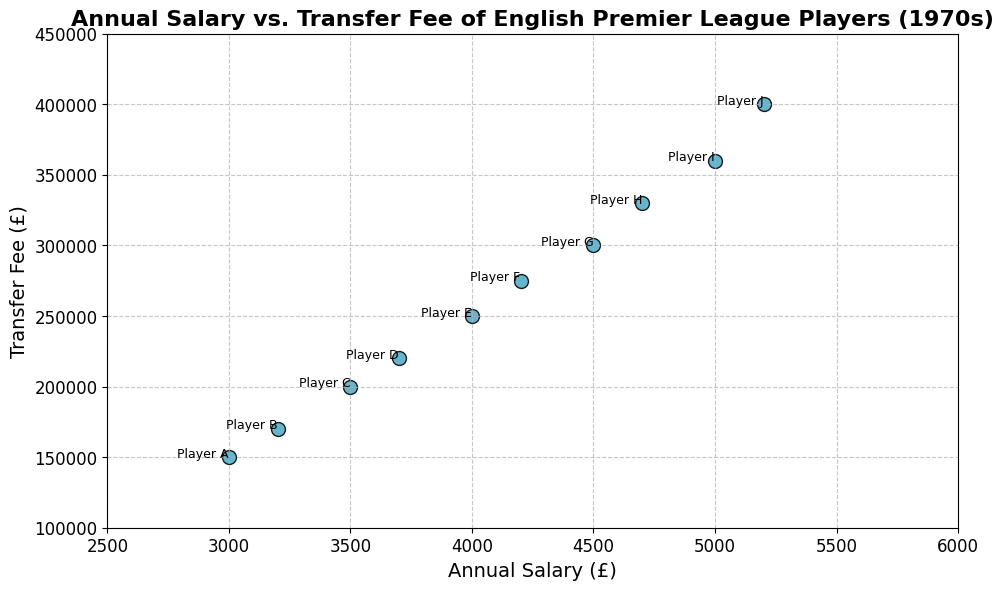Which player had the highest annual salary? By checking the scatter plot, we can see the player with the highest vertical position in terms of annual salary.
Answer: Player J Which player had the lowest transfer fee? Examine the scatter plot for the point with the lowest vertical position, which indicates the lowest transfer fee.
Answer: Player A How did the transfer fee trend over the decade? Observing the scatter plot, the transfer fees generally increase from left to right along the x-axis, indicating that they rise as the years progress.
Answer: Increasing What is the difference between the highest and lowest annual salaries? The highest annual salary is £5200 (Player J) and the lowest is £3000 (Player A). The difference is £5200 - £3000.
Answer: £2200 Which players had a transfer fee greater than £300,000? Identify the points with a vertical position greater than £300,000 on the scatter plot.
Answer: Players H, I, J How many players had an annual salary greater than £4500? Count the points with an annual salary (x-axis) position greater than £4500 on the scatter plot.
Answer: 3 Was there a strong correlation between annual salary and transfer fee? Given that the scatter plot shows that higher annual salaries generally correspond to higher transfer fees, this indicates a strong positive correlation.
Answer: Yes Which year had the player with the lowest annual salary? By cross-referencing the player with the lowest annual salary, we find Player A, who was from the year 1970.
Answer: 1970 What was the average transfer fee for players with an annual salary above £4000? Players with an annual salary above £4000 are F, G, H, I, and J. Their transfer fees are £275,000, £300,000, £330,000, £360,000, and £400,000 respectively. The average is calculated as (£275,000 + £300,000 + £330,000 + £360,000 + £400,000) / 5.
Answer: £333,000 